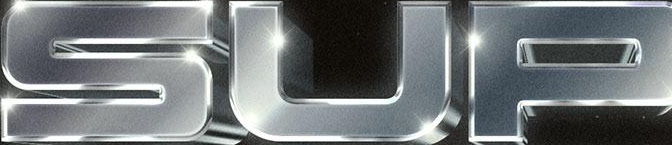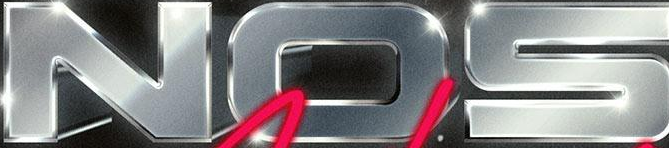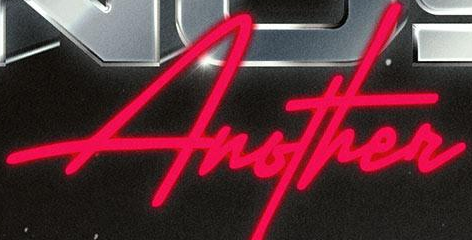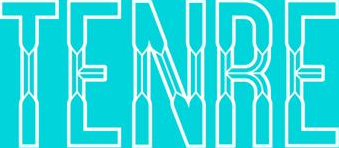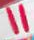Read the text content from these images in order, separated by a semicolon. SUP; NOS; Another; TENRE; " 